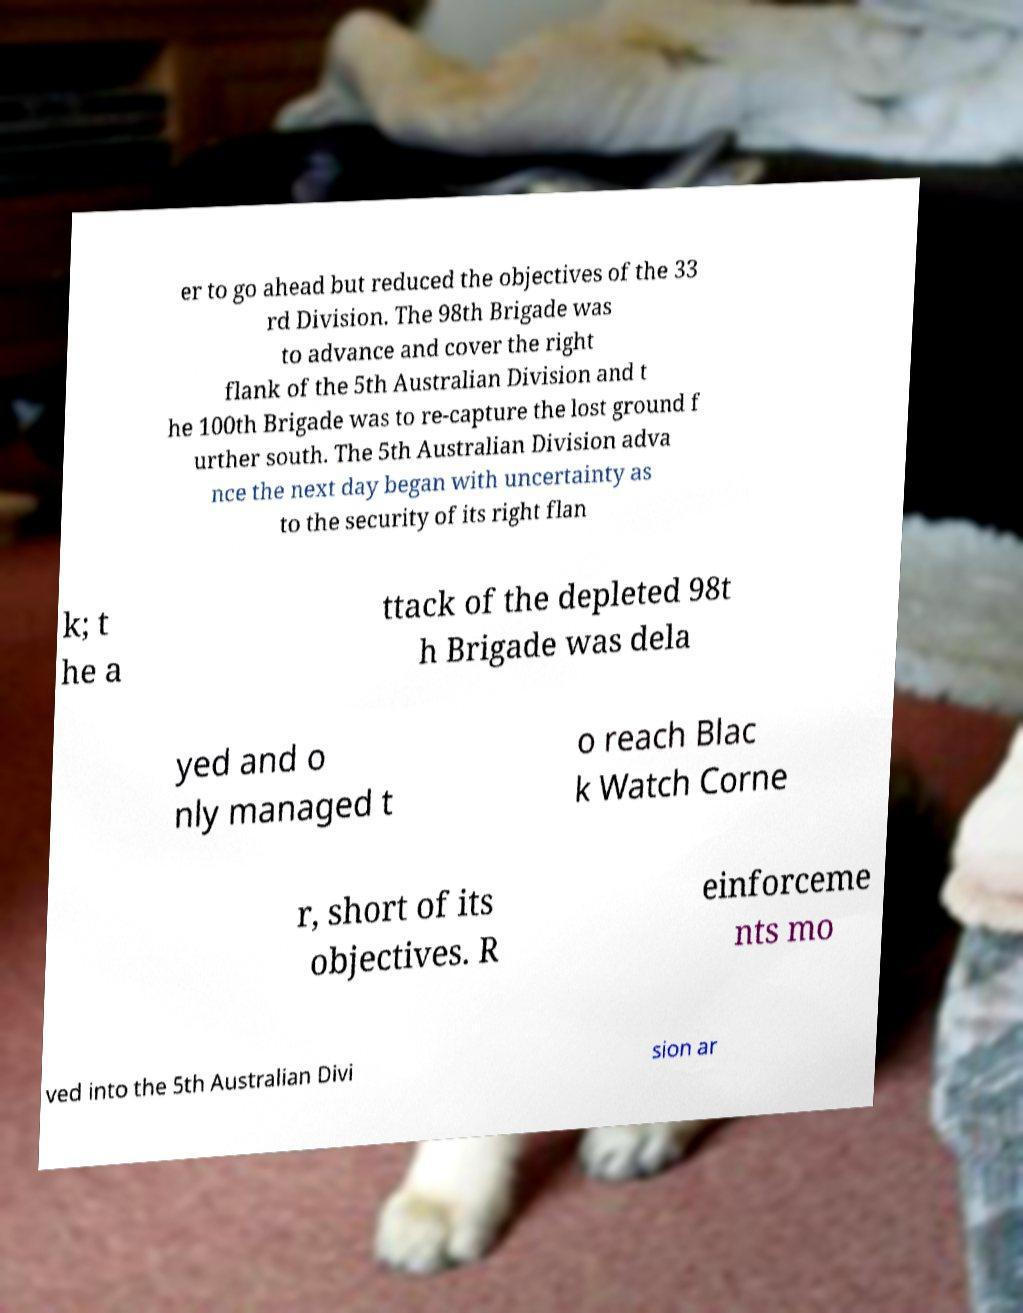Please identify and transcribe the text found in this image. er to go ahead but reduced the objectives of the 33 rd Division. The 98th Brigade was to advance and cover the right flank of the 5th Australian Division and t he 100th Brigade was to re-capture the lost ground f urther south. The 5th Australian Division adva nce the next day began with uncertainty as to the security of its right flan k; t he a ttack of the depleted 98t h Brigade was dela yed and o nly managed t o reach Blac k Watch Corne r, short of its objectives. R einforceme nts mo ved into the 5th Australian Divi sion ar 